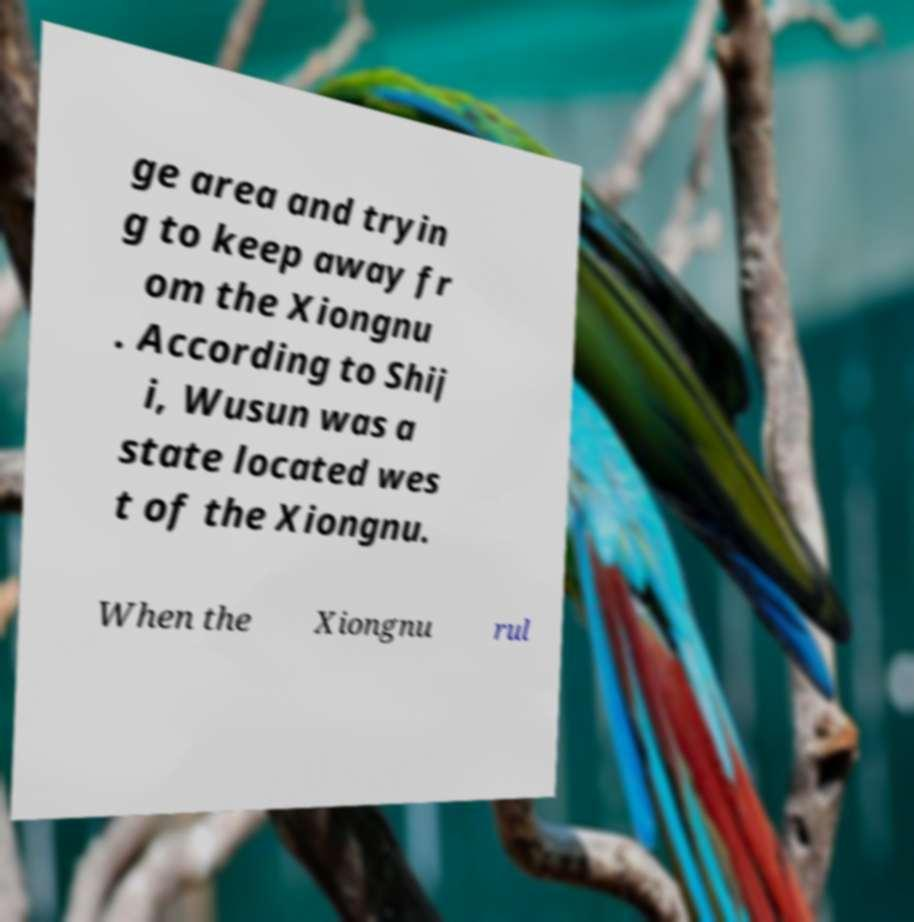Could you extract and type out the text from this image? ge area and tryin g to keep away fr om the Xiongnu . According to Shij i, Wusun was a state located wes t of the Xiongnu. When the Xiongnu rul 